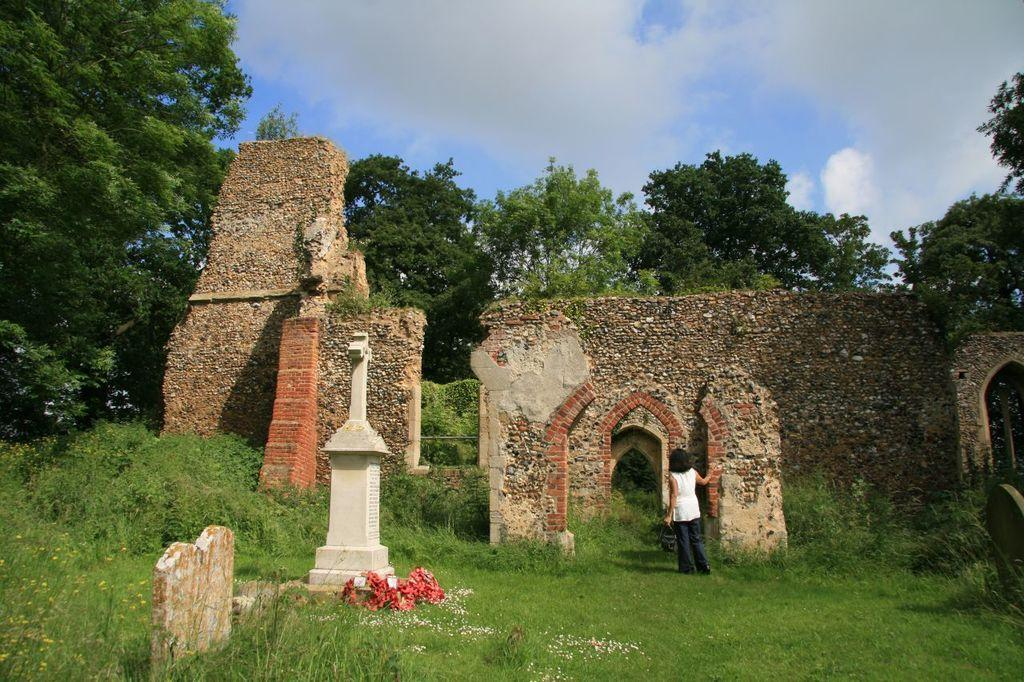What is the main subject of the image? The main subject of the image is a collapsed building. Is there anyone present in the image? Yes, there is a person standing in front of the building. What is the person standing on? The person is standing on grass. What can be seen in the sky in the image? The sky is visible in the image. Are there any trees in the image? Yes, there is a tree at the top of the image. What type of pies is the person holding in the image? There are no pies present in the image; the person is standing in front of a collapsed building. What drink is the grandmother offering to the person in the image? There is no grandmother or drink present in the image. 